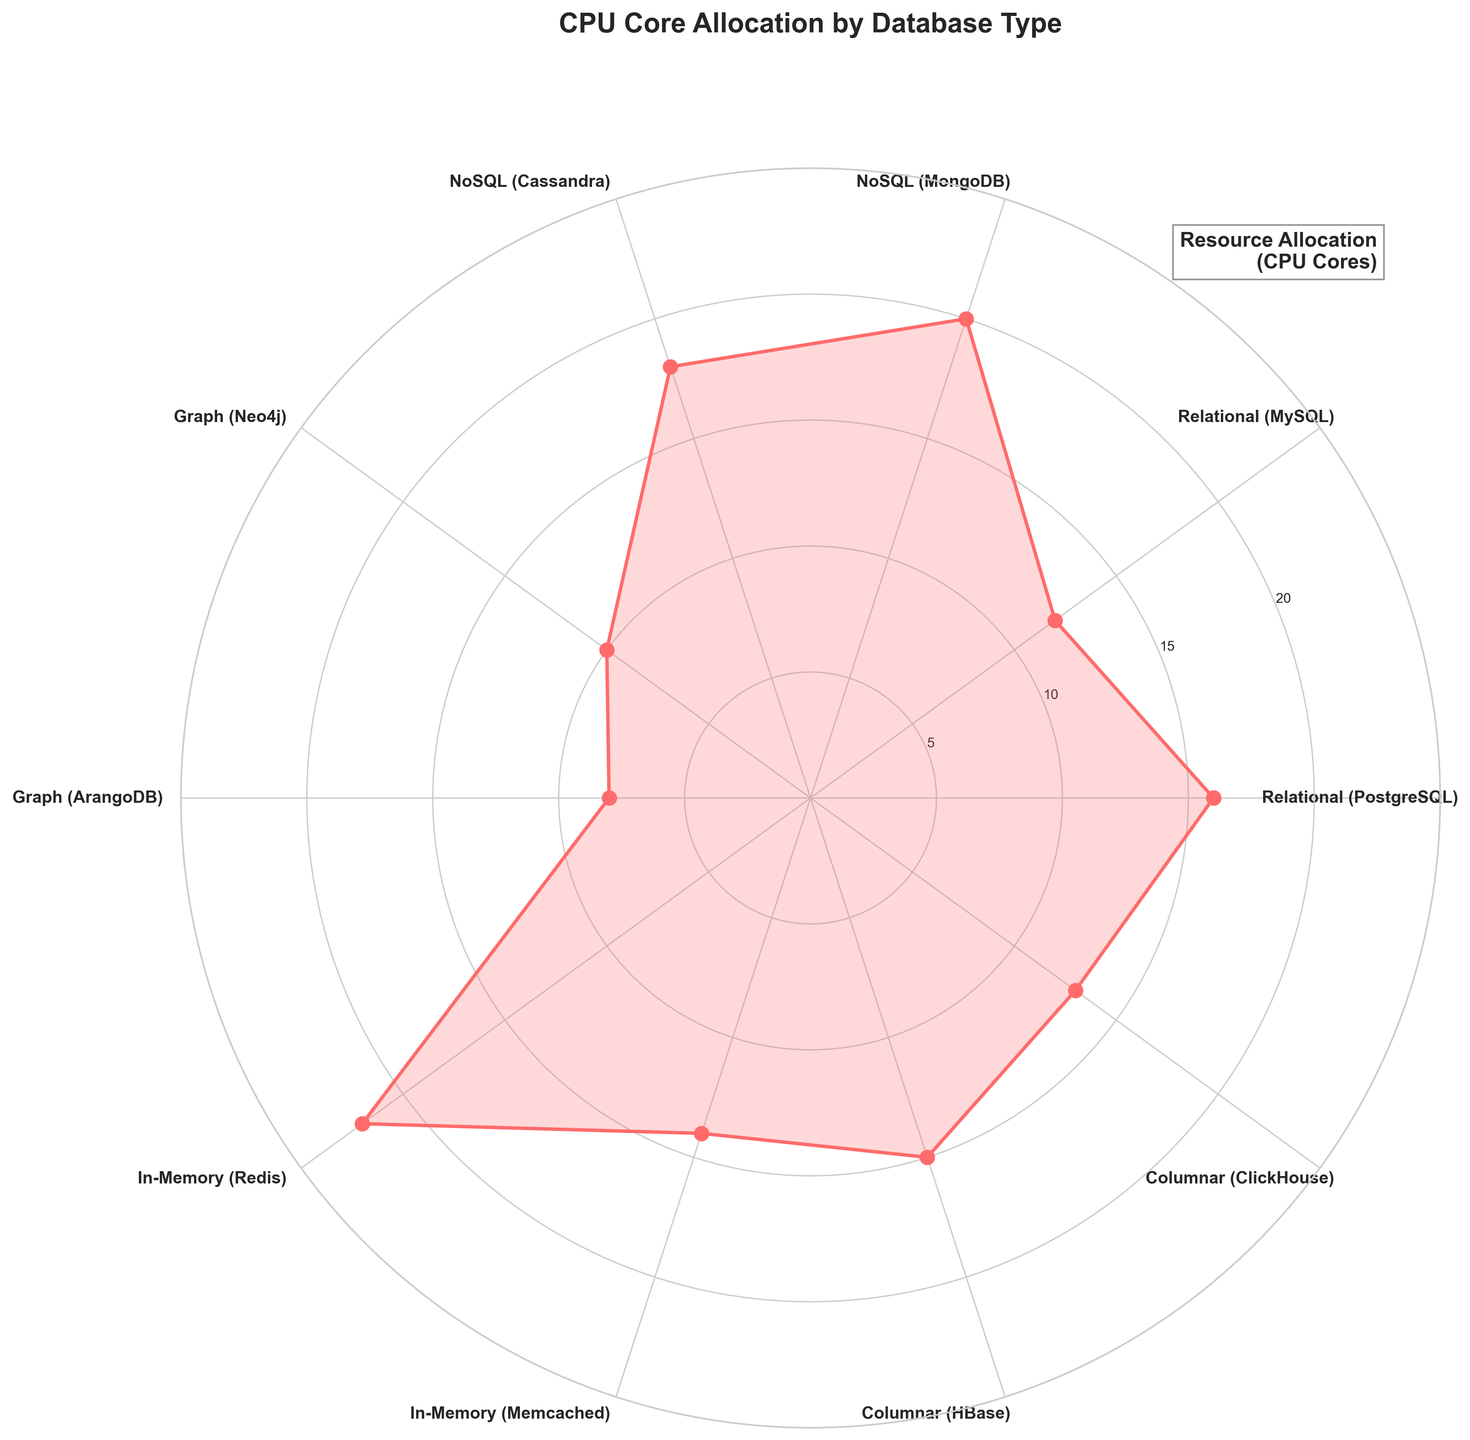What is the title of the plot? The title is usually placed at the top of the chart and describes what the figure is about. Here, it clearly states "CPU Core Allocation by Database Type".
Answer: CPU Core Allocation by Database Type Which database type has the highest resource allocation in CPU cores? By observing the plot, the highest point on the radial axis is located at the edge of the circular chart and points to the database type. In the figure, this is clearly represented by "Redis".
Answer: Redis How many database types are represented in the plot? You can count the number of labels around the edge of the polar plot. Each label represents a different database type. In this scenario, there are 10 different labels.
Answer: 10 What is the resource allocation for PostgreSQL in CPU cores? Find the point labeled "PostgreSQL" and look at its position on the radial axis. The value closest to this point is 16.
Answer: 16 Which database type has the lowest resource allocation in CPU cores? The lowest point on the radial axis indicates the database type with the least resource allocation. Here, that point corresponds to "Memcached".
Answer: Memcached What is the total CPU core allocation for NoSQL database types? Add the values for MongoDB and Cassandra since these are classified as NoSQL in the data. MongoDB has 20 CPU cores, and Cassandra has 18 CPU cores; the sum is 38.
Answer: 38 Which has more CPU cores allocated, MySQL or ClickHouse? Compare the positions of MySQL and ClickHouse on the radial axis. MySQL has 12 CPU cores, whereas ClickHouse has 13 CPU cores. Therefore, ClickHouse has more.
Answer: ClickHouse What is the average resource allocation in CPU cores for Graph database types? The Graph database types are Neo4j and ArangoDB. Neo4j has 10 CPU cores, and ArangoDB has 8 CPU cores. The average is (10 + 8) / 2 = 9.
Answer: 9 By how much does Redis's CPU core allocation exceed that of Memcached? Redis has 22 CPU cores, and Memcached has 14 CPU cores. The difference is 22 - 14 = 8.
Answer: 8 What pattern can you observe about the resource allocation for In-Memory databases? Both In-Memory databases Redis and Memcached have allocations that are skewed, one being significantly higher in CPU cores than the other. Alternatively, you may note that Redis has the maximum allocation overall.
Answer: High disparity between Redis and Memcached 